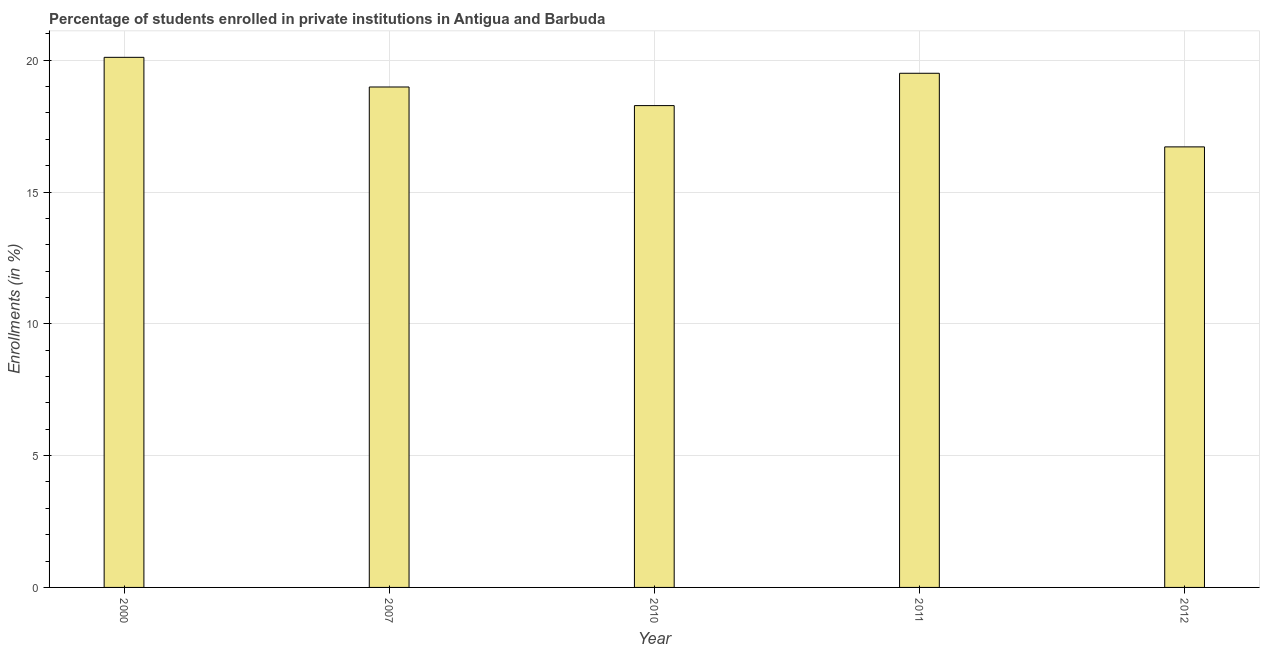Does the graph contain grids?
Offer a terse response. Yes. What is the title of the graph?
Ensure brevity in your answer.  Percentage of students enrolled in private institutions in Antigua and Barbuda. What is the label or title of the Y-axis?
Your response must be concise. Enrollments (in %). What is the enrollments in private institutions in 2010?
Give a very brief answer. 18.28. Across all years, what is the maximum enrollments in private institutions?
Offer a terse response. 20.11. Across all years, what is the minimum enrollments in private institutions?
Provide a short and direct response. 16.71. In which year was the enrollments in private institutions maximum?
Provide a succinct answer. 2000. In which year was the enrollments in private institutions minimum?
Ensure brevity in your answer.  2012. What is the sum of the enrollments in private institutions?
Your answer should be very brief. 93.59. What is the difference between the enrollments in private institutions in 2000 and 2012?
Give a very brief answer. 3.4. What is the average enrollments in private institutions per year?
Make the answer very short. 18.72. What is the median enrollments in private institutions?
Your answer should be compact. 18.98. Do a majority of the years between 2011 and 2010 (inclusive) have enrollments in private institutions greater than 10 %?
Your answer should be very brief. No. Is the enrollments in private institutions in 2011 less than that in 2012?
Your answer should be very brief. No. What is the difference between the highest and the second highest enrollments in private institutions?
Ensure brevity in your answer.  0.6. In how many years, is the enrollments in private institutions greater than the average enrollments in private institutions taken over all years?
Your answer should be very brief. 3. Are all the bars in the graph horizontal?
Provide a short and direct response. No. What is the Enrollments (in %) in 2000?
Give a very brief answer. 20.11. What is the Enrollments (in %) of 2007?
Your answer should be compact. 18.98. What is the Enrollments (in %) of 2010?
Provide a short and direct response. 18.28. What is the Enrollments (in %) of 2011?
Offer a terse response. 19.51. What is the Enrollments (in %) of 2012?
Make the answer very short. 16.71. What is the difference between the Enrollments (in %) in 2000 and 2007?
Your response must be concise. 1.13. What is the difference between the Enrollments (in %) in 2000 and 2010?
Give a very brief answer. 1.83. What is the difference between the Enrollments (in %) in 2000 and 2011?
Give a very brief answer. 0.6. What is the difference between the Enrollments (in %) in 2000 and 2012?
Provide a succinct answer. 3.4. What is the difference between the Enrollments (in %) in 2007 and 2010?
Ensure brevity in your answer.  0.71. What is the difference between the Enrollments (in %) in 2007 and 2011?
Ensure brevity in your answer.  -0.52. What is the difference between the Enrollments (in %) in 2007 and 2012?
Keep it short and to the point. 2.27. What is the difference between the Enrollments (in %) in 2010 and 2011?
Your answer should be very brief. -1.23. What is the difference between the Enrollments (in %) in 2010 and 2012?
Your answer should be very brief. 1.57. What is the difference between the Enrollments (in %) in 2011 and 2012?
Provide a succinct answer. 2.79. What is the ratio of the Enrollments (in %) in 2000 to that in 2007?
Ensure brevity in your answer.  1.06. What is the ratio of the Enrollments (in %) in 2000 to that in 2011?
Ensure brevity in your answer.  1.03. What is the ratio of the Enrollments (in %) in 2000 to that in 2012?
Offer a terse response. 1.2. What is the ratio of the Enrollments (in %) in 2007 to that in 2010?
Your answer should be very brief. 1.04. What is the ratio of the Enrollments (in %) in 2007 to that in 2012?
Make the answer very short. 1.14. What is the ratio of the Enrollments (in %) in 2010 to that in 2011?
Provide a succinct answer. 0.94. What is the ratio of the Enrollments (in %) in 2010 to that in 2012?
Provide a succinct answer. 1.09. What is the ratio of the Enrollments (in %) in 2011 to that in 2012?
Provide a short and direct response. 1.17. 